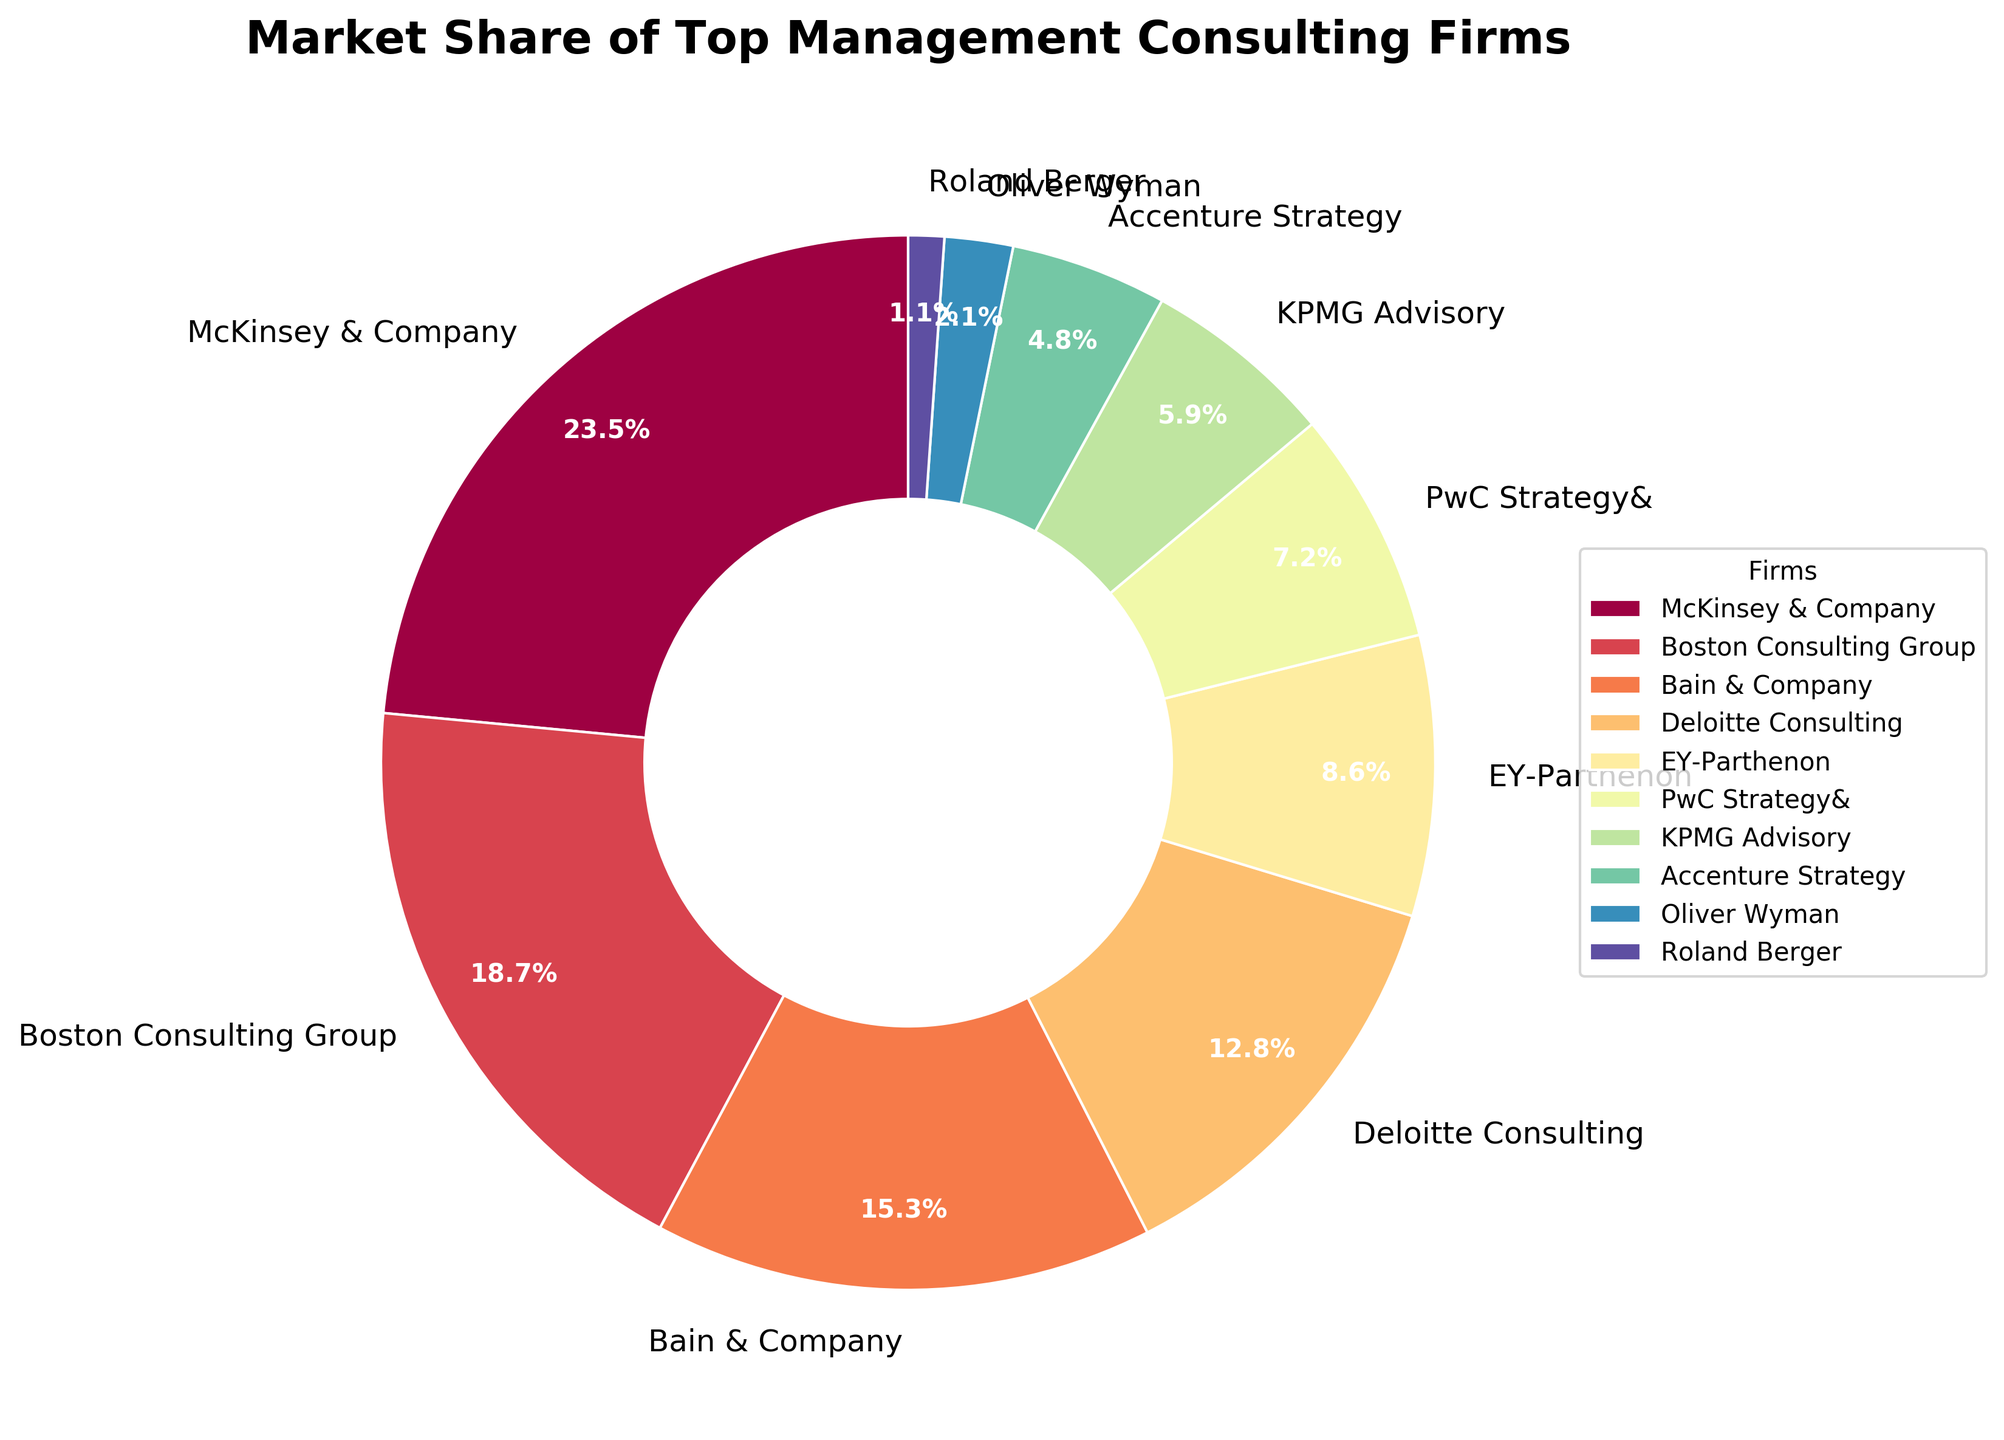What is the market share of McKinsey & Company? The figure displays the market share for each consulting firm. Locate the label for McKinsey & Company and read off the corresponding market share percentage.
Answer: 23.5% What are the combined market shares of Boston Consulting Group and Bain & Company? Sum the individual market shares of Boston Consulting Group (18.7%) and Bain & Company (15.3%).
Answer: 34.0% Which firm has the smallest market share? The figure displays all the market shares. Identify the firm with the smallest percentage, which is Roland Berger with 1.1%.
Answer: Roland Berger How much larger is Deloitte Consulting's market share than EY-Parthenon's? Subtract EY-Parthenon's market share (8.6%) from Deloitte Consulting's market share (12.8%).
Answer: 4.2% List the firms whose market share is above 10%. Identify the firms with market shares greater than 10%. They are McKinsey & Company (23.5%), Boston Consulting Group (18.7%), Bain & Company (15.3%), and Deloitte Consulting (12.8%).
Answer: McKinsey & Company, Boston Consulting Group, Bain & Company, Deloitte Consulting Which firm has more market share: PwC Strategy& or KPMG Advisory? Compare the market shares of PwC Strategy& (7.2%) and KPMG Advisory (5.9%). PwC Strategy& has a larger market share.
Answer: PwC Strategy& What is the average market share of the firms listed? Sum all the market shares and divide by the number of firms. Total market share is 100%. With 10 firms, the average market share is 100 / 10 = 10%.
Answer: 10% How many firms have a market share less than 5%? Count the firms with a market share less than 5%. They are Accenture Strategy (4.8%), Oliver Wyman (2.1%), and Roland Berger (1.1%), giving a total of 3 firms.
Answer: 3 Which firm has a market share closest to 6%? Identify the firm whose market share is closest to 6%, which is KPMG Advisory with 5.9%.
Answer: KPMG Advisory 